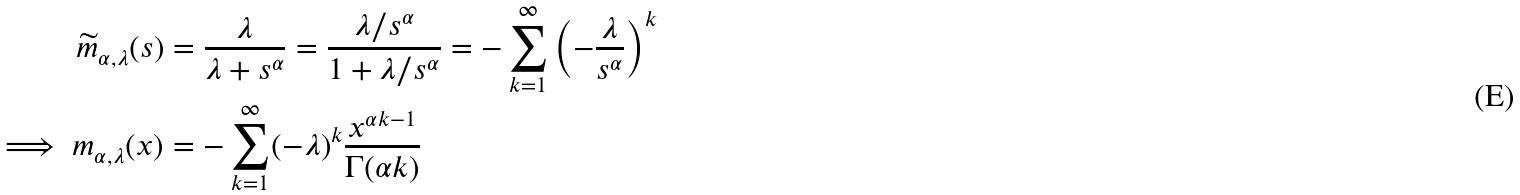Convert formula to latex. <formula><loc_0><loc_0><loc_500><loc_500>\widetilde { m } _ { \alpha , \lambda } ( s ) & = \frac { \lambda } { \lambda + s ^ { \alpha } } = \frac { \lambda / s ^ { \alpha } } { 1 + \lambda / s ^ { \alpha } } = - \sum _ { k = 1 } ^ { \infty } \left ( - \frac { \lambda } { s ^ { \alpha } } \right ) ^ { k } \\ \implies m _ { \alpha , \lambda } ( x ) & = - \sum _ { k = 1 } ^ { \infty } ( - \lambda ) ^ { k } \frac { x ^ { \alpha k - 1 } } { \Gamma ( \alpha k ) }</formula> 